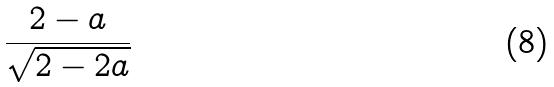<formula> <loc_0><loc_0><loc_500><loc_500>\frac { 2 - a } { \sqrt { 2 - 2 a } }</formula> 